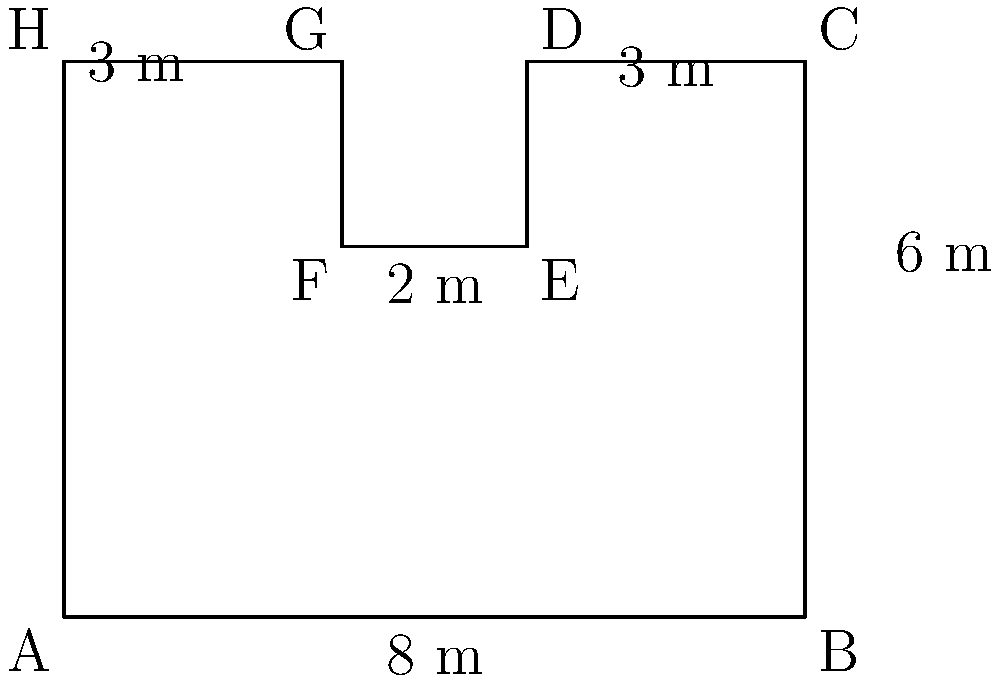You're designing a new dog park in the senior's neighborhood with an irregular shape as shown in the diagram. Calculate the total area of the dog park in square meters. To find the area of this irregular shape, we can divide it into rectangles and calculate their areas separately:

1. Main rectangle (ABCH):
   Area = $8 \text{ m} \times 6 \text{ m} = 48 \text{ m}^2$

2. Subtract the area of rectangle DEFG:
   Area to subtract = $2 \text{ m} \times 2 \text{ m} = 4 \text{ m}^2$

Total area = Area of main rectangle - Area to subtract
           = $48 \text{ m}^2 - 4 \text{ m}^2 = 44 \text{ m}^2$

Therefore, the total area of the dog park is $44 \text{ m}^2$.
Answer: $44 \text{ m}^2$ 